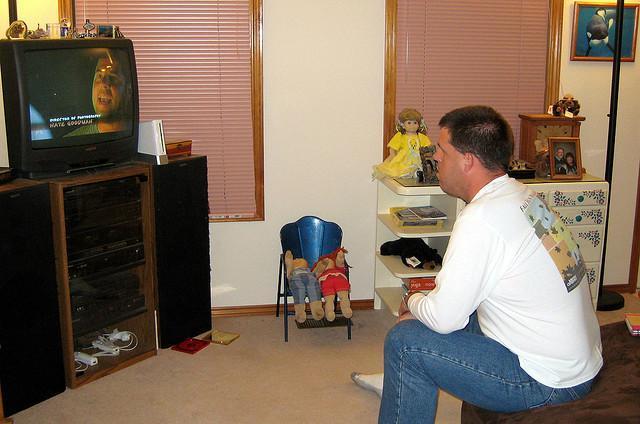How many people can be seen?
Give a very brief answer. 2. 